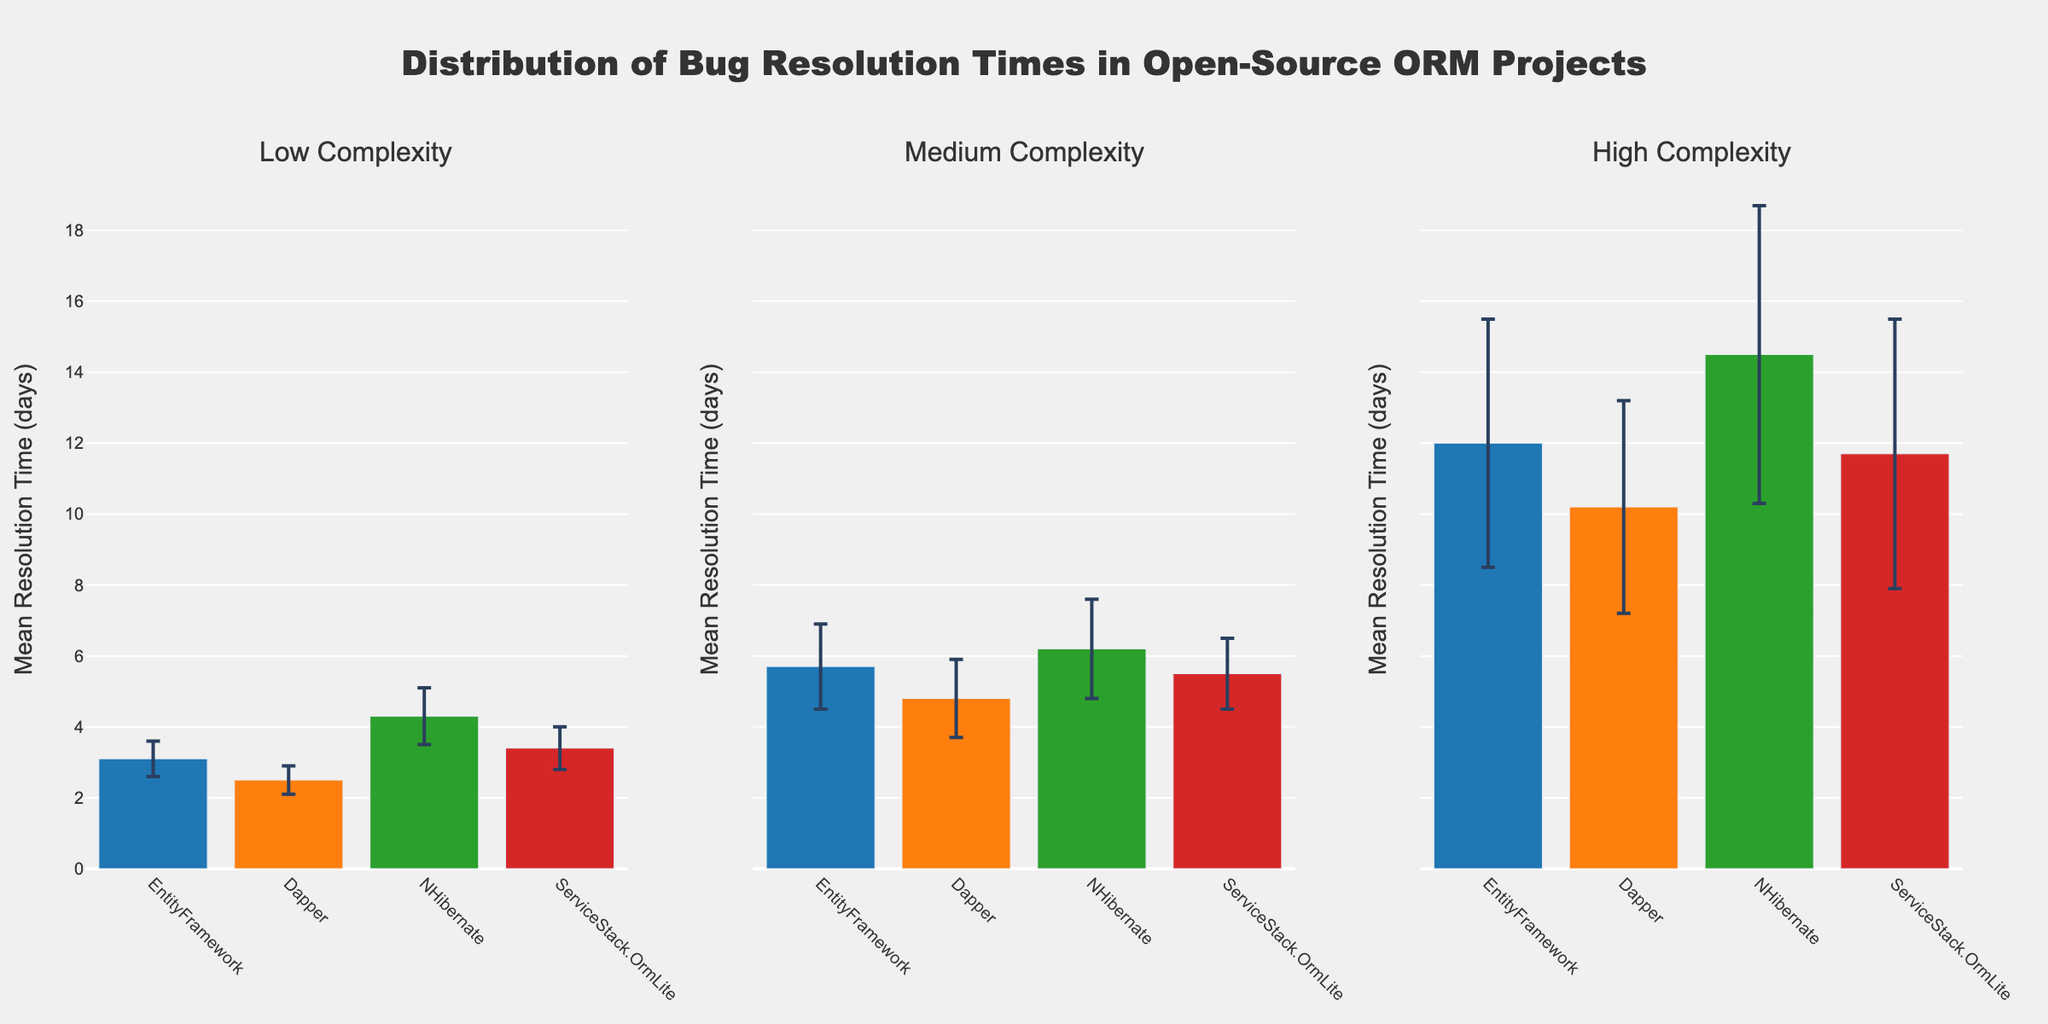What is the title of the figure? The title is displayed at the top of the figure in a prominent font. It reads "Distribution of Bug Resolution Times in Open-Source ORM Projects".
Answer: Distribution of Bug Resolution Times in Open-Source ORM Projects What are the three subplots representing? Each subplot represents bug resolution times categorized by complexity levels. The titles of the subplots are "Low Complexity", "Medium Complexity", and "High Complexity", as shown at the top of each subplot.
Answer: Low Complexity, Medium Complexity, High Complexity Which ORM project has the lowest mean bug resolution time for Low Complexity issues? By examining the leftmost subplot (Low Complexity), the bar with the smallest height represents Dapper with a mean resolution time of 2.5 days.
Answer: Dapper What is the average mean resolution time for High Complexity bugs across all ORM projects? First, sum the mean resolution times shown in the rightmost subplot: EntityFramework (12.0), Dapper (10.2), NHibernate (14.5), and ServiceStack.OrmLite (11.7). Then, the average is (12.0 + 10.2 + 14.5 + 11.7) / 4 = 12.1 days.
Answer: 12.1 days Which ORM project shows the highest standard deviation for any complexity level? By looking at the error bars across all subplots, NHibernate in the High Complexity subplot has the largest error bar with a standard deviation of 4.2 days.
Answer: NHibernate Does the mean resolution time for Medium Complexity issues in Dapper exceed 5 days? From the middle subplot (Medium Complexity), the bar for Dapper indicates a mean resolution time of 4.8 days, which is less than 5 days.
Answer: No Compare the mean resolution times for Low Complexity issues between EntityFramework and ServiceStack.OrmLite. In the Low Complexity subplot, the bars for EntityFramework and ServiceStack.OrmLite show mean resolution times of 3.1 and 3.4 days, respectively. EntityFramework has a lower mean resolution time.
Answer: EntityFramework Which project has consistent resolution times across all complexity levels, considering mean and standard deviation? By comparing the bars and error bars across all subplots, Dapper has relatively lower mean values and smaller error bars, indicating more consistent resolution times.
Answer: Dapper 